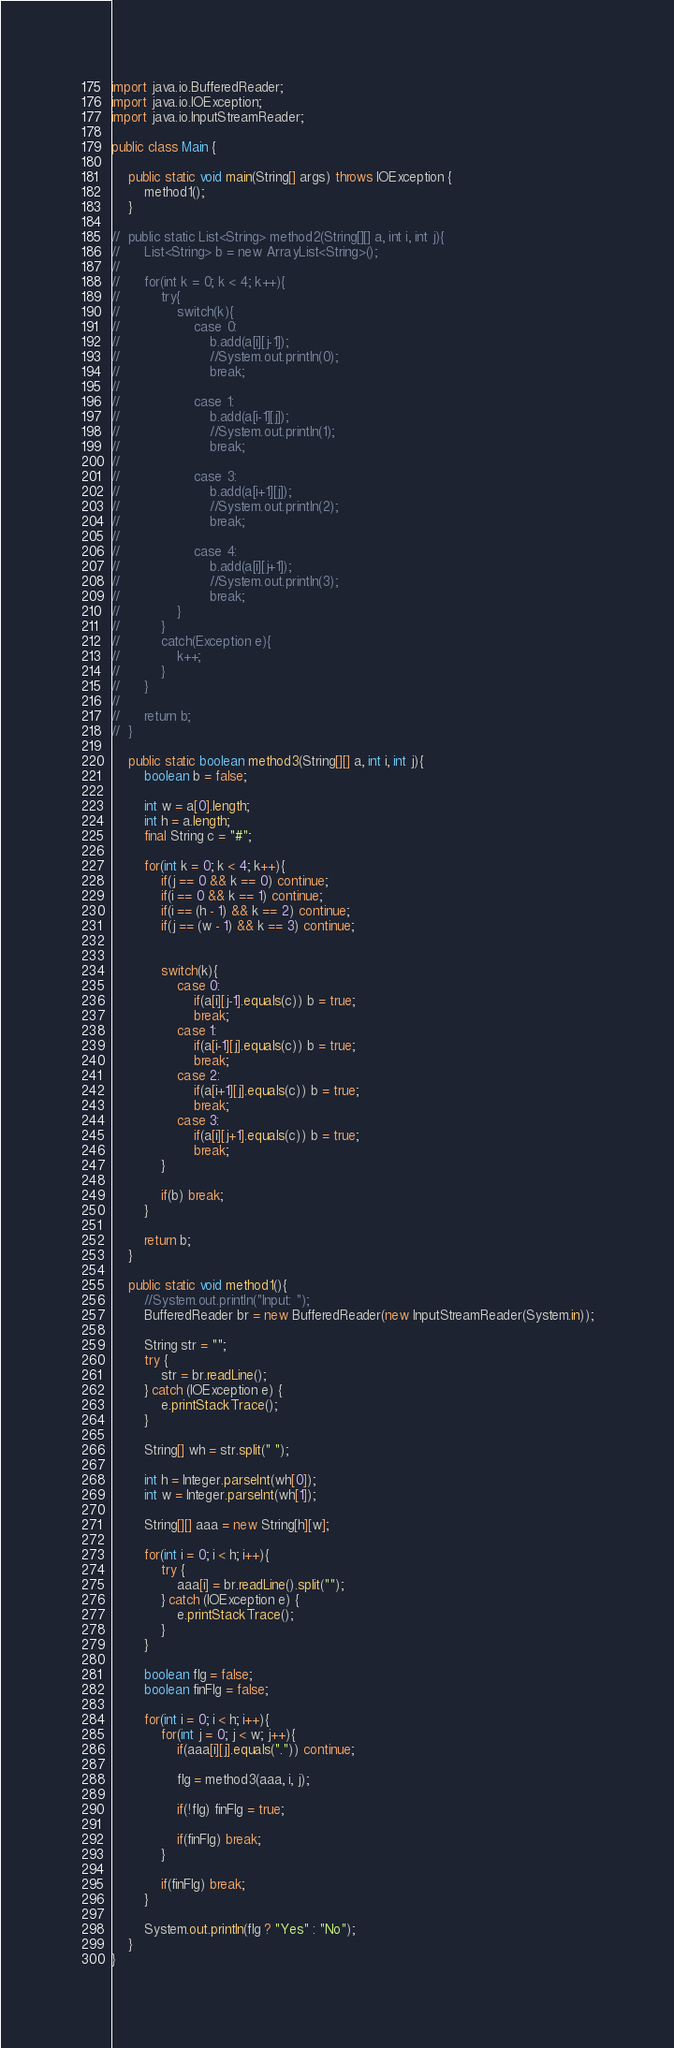<code> <loc_0><loc_0><loc_500><loc_500><_Java_>import java.io.BufferedReader;
import java.io.IOException;
import java.io.InputStreamReader;

public class Main {

	public static void main(String[] args) throws IOException {
		method1();
	}
	
//	public static List<String> method2(String[][] a, int i, int j){
//		List<String> b = new ArrayList<String>();
//		
//		for(int k = 0; k < 4; k++){
//			try{
//				switch(k){
//					case 0:
//						b.add(a[i][j-1]);
//						//System.out.println(0);
//						break;
//						
//					case 1:
//						b.add(a[i-1][j]);
//						//System.out.println(1);
//						break;
//						
//					case 3:
//						b.add(a[i+1][j]);
//						//System.out.println(2);
//						break;
//						
//					case 4:
//						b.add(a[i][j+1]);
//						//System.out.println(3);
//						break;
//				}
//			}
//			catch(Exception e){
//				k++;
//			}
//		}
//		
//		return b;
//	}
	
	public static boolean method3(String[][] a, int i, int j){
		boolean b = false;
		
		int w = a[0].length;
		int h = a.length;
		final String c = "#";
		
		for(int k = 0; k < 4; k++){
			if(j == 0 && k == 0) continue;
			if(i == 0 && k == 1) continue;
			if(i == (h - 1) && k == 2) continue;
			if(j == (w - 1) && k == 3) continue;
			
			
			switch(k){
				case 0:
					if(a[i][j-1].equals(c)) b = true;
					break;
				case 1:
					if(a[i-1][j].equals(c)) b = true;
					break;
				case 2:
					if(a[i+1][j].equals(c)) b = true;
					break;
				case 3:
					if(a[i][j+1].equals(c)) b = true;
					break;
			}
			
			if(b) break;
		}
		
		return b;
	}
	
	public static void method1(){
		//System.out.println("Input: ");
		BufferedReader br = new BufferedReader(new InputStreamReader(System.in));
		
		String str = "";
		try {
			str = br.readLine();
		} catch (IOException e) {
			e.printStackTrace();
		}
		
		String[] wh = str.split(" ");
		
		int h = Integer.parseInt(wh[0]);
		int w = Integer.parseInt(wh[1]);
		
		String[][] aaa = new String[h][w];
		
		for(int i = 0; i < h; i++){
			try {
				aaa[i] = br.readLine().split("");
			} catch (IOException e) {
				e.printStackTrace();
			}
		}
		
		boolean flg = false;
		boolean finFlg = false;
		
		for(int i = 0; i < h; i++){
			for(int j = 0; j < w; j++){
				if(aaa[i][j].equals(".")) continue;
				
				flg = method3(aaa, i, j);
				
				if(!flg) finFlg = true; 
				
				if(finFlg) break;
			}
			
			if(finFlg) break;
		}
		
		System.out.println(flg ? "Yes" : "No");
	}
}
</code> 